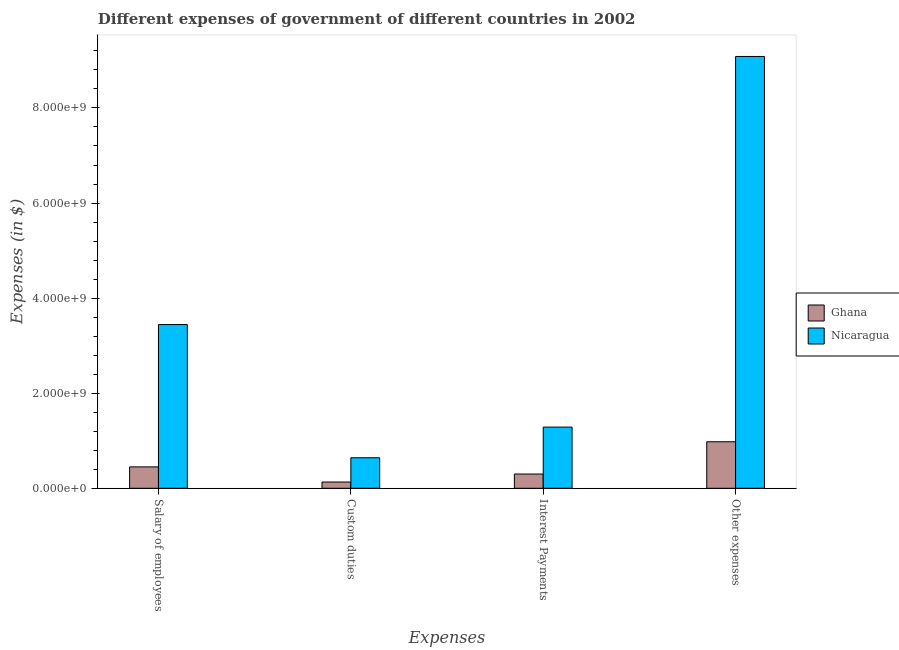How many different coloured bars are there?
Offer a terse response. 2. What is the label of the 4th group of bars from the left?
Keep it short and to the point. Other expenses. What is the amount spent on other expenses in Nicaragua?
Give a very brief answer. 9.08e+09. Across all countries, what is the maximum amount spent on custom duties?
Your answer should be compact. 6.42e+08. Across all countries, what is the minimum amount spent on interest payments?
Your response must be concise. 3.00e+08. In which country was the amount spent on interest payments maximum?
Provide a succinct answer. Nicaragua. What is the total amount spent on other expenses in the graph?
Your answer should be compact. 1.01e+1. What is the difference between the amount spent on custom duties in Nicaragua and that in Ghana?
Provide a succinct answer. 5.10e+08. What is the difference between the amount spent on salary of employees in Nicaragua and the amount spent on custom duties in Ghana?
Your response must be concise. 3.31e+09. What is the average amount spent on salary of employees per country?
Keep it short and to the point. 1.95e+09. What is the difference between the amount spent on custom duties and amount spent on interest payments in Ghana?
Your response must be concise. -1.68e+08. In how many countries, is the amount spent on salary of employees greater than 8800000000 $?
Ensure brevity in your answer.  0. What is the ratio of the amount spent on salary of employees in Nicaragua to that in Ghana?
Your answer should be very brief. 7.65. Is the difference between the amount spent on salary of employees in Nicaragua and Ghana greater than the difference between the amount spent on other expenses in Nicaragua and Ghana?
Make the answer very short. No. What is the difference between the highest and the second highest amount spent on interest payments?
Your answer should be compact. 9.87e+08. What is the difference between the highest and the lowest amount spent on interest payments?
Make the answer very short. 9.87e+08. In how many countries, is the amount spent on salary of employees greater than the average amount spent on salary of employees taken over all countries?
Provide a short and direct response. 1. Is it the case that in every country, the sum of the amount spent on salary of employees and amount spent on custom duties is greater than the sum of amount spent on other expenses and amount spent on interest payments?
Keep it short and to the point. No. What does the 1st bar from the left in Other expenses represents?
Offer a very short reply. Ghana. What does the 1st bar from the right in Interest Payments represents?
Provide a succinct answer. Nicaragua. Are the values on the major ticks of Y-axis written in scientific E-notation?
Keep it short and to the point. Yes. Does the graph contain grids?
Offer a very short reply. No. How are the legend labels stacked?
Make the answer very short. Vertical. What is the title of the graph?
Offer a terse response. Different expenses of government of different countries in 2002. What is the label or title of the X-axis?
Keep it short and to the point. Expenses. What is the label or title of the Y-axis?
Provide a succinct answer. Expenses (in $). What is the Expenses (in $) in Ghana in Salary of employees?
Ensure brevity in your answer.  4.50e+08. What is the Expenses (in $) of Nicaragua in Salary of employees?
Give a very brief answer. 3.44e+09. What is the Expenses (in $) of Ghana in Custom duties?
Offer a terse response. 1.32e+08. What is the Expenses (in $) in Nicaragua in Custom duties?
Give a very brief answer. 6.42e+08. What is the Expenses (in $) in Ghana in Interest Payments?
Give a very brief answer. 3.00e+08. What is the Expenses (in $) of Nicaragua in Interest Payments?
Provide a succinct answer. 1.29e+09. What is the Expenses (in $) in Ghana in Other expenses?
Your response must be concise. 9.79e+08. What is the Expenses (in $) in Nicaragua in Other expenses?
Keep it short and to the point. 9.08e+09. Across all Expenses, what is the maximum Expenses (in $) in Ghana?
Offer a terse response. 9.79e+08. Across all Expenses, what is the maximum Expenses (in $) of Nicaragua?
Offer a terse response. 9.08e+09. Across all Expenses, what is the minimum Expenses (in $) of Ghana?
Make the answer very short. 1.32e+08. Across all Expenses, what is the minimum Expenses (in $) of Nicaragua?
Ensure brevity in your answer.  6.42e+08. What is the total Expenses (in $) of Ghana in the graph?
Your answer should be compact. 1.86e+09. What is the total Expenses (in $) of Nicaragua in the graph?
Offer a very short reply. 1.45e+1. What is the difference between the Expenses (in $) of Ghana in Salary of employees and that in Custom duties?
Offer a terse response. 3.18e+08. What is the difference between the Expenses (in $) in Nicaragua in Salary of employees and that in Custom duties?
Make the answer very short. 2.80e+09. What is the difference between the Expenses (in $) of Ghana in Salary of employees and that in Interest Payments?
Your answer should be compact. 1.50e+08. What is the difference between the Expenses (in $) in Nicaragua in Salary of employees and that in Interest Payments?
Offer a very short reply. 2.16e+09. What is the difference between the Expenses (in $) of Ghana in Salary of employees and that in Other expenses?
Offer a very short reply. -5.29e+08. What is the difference between the Expenses (in $) of Nicaragua in Salary of employees and that in Other expenses?
Provide a succinct answer. -5.64e+09. What is the difference between the Expenses (in $) in Ghana in Custom duties and that in Interest Payments?
Make the answer very short. -1.68e+08. What is the difference between the Expenses (in $) of Nicaragua in Custom duties and that in Interest Payments?
Your answer should be compact. -6.45e+08. What is the difference between the Expenses (in $) of Ghana in Custom duties and that in Other expenses?
Provide a short and direct response. -8.47e+08. What is the difference between the Expenses (in $) in Nicaragua in Custom duties and that in Other expenses?
Offer a very short reply. -8.44e+09. What is the difference between the Expenses (in $) of Ghana in Interest Payments and that in Other expenses?
Your answer should be very brief. -6.79e+08. What is the difference between the Expenses (in $) of Nicaragua in Interest Payments and that in Other expenses?
Offer a very short reply. -7.80e+09. What is the difference between the Expenses (in $) of Ghana in Salary of employees and the Expenses (in $) of Nicaragua in Custom duties?
Provide a succinct answer. -1.92e+08. What is the difference between the Expenses (in $) of Ghana in Salary of employees and the Expenses (in $) of Nicaragua in Interest Payments?
Offer a very short reply. -8.37e+08. What is the difference between the Expenses (in $) in Ghana in Salary of employees and the Expenses (in $) in Nicaragua in Other expenses?
Give a very brief answer. -8.63e+09. What is the difference between the Expenses (in $) in Ghana in Custom duties and the Expenses (in $) in Nicaragua in Interest Payments?
Keep it short and to the point. -1.16e+09. What is the difference between the Expenses (in $) of Ghana in Custom duties and the Expenses (in $) of Nicaragua in Other expenses?
Offer a very short reply. -8.95e+09. What is the difference between the Expenses (in $) of Ghana in Interest Payments and the Expenses (in $) of Nicaragua in Other expenses?
Your answer should be compact. -8.78e+09. What is the average Expenses (in $) of Ghana per Expenses?
Your answer should be very brief. 4.65e+08. What is the average Expenses (in $) in Nicaragua per Expenses?
Give a very brief answer. 3.61e+09. What is the difference between the Expenses (in $) in Ghana and Expenses (in $) in Nicaragua in Salary of employees?
Keep it short and to the point. -2.99e+09. What is the difference between the Expenses (in $) of Ghana and Expenses (in $) of Nicaragua in Custom duties?
Provide a succinct answer. -5.10e+08. What is the difference between the Expenses (in $) in Ghana and Expenses (in $) in Nicaragua in Interest Payments?
Give a very brief answer. -9.87e+08. What is the difference between the Expenses (in $) in Ghana and Expenses (in $) in Nicaragua in Other expenses?
Your answer should be compact. -8.10e+09. What is the ratio of the Expenses (in $) in Ghana in Salary of employees to that in Custom duties?
Make the answer very short. 3.42. What is the ratio of the Expenses (in $) of Nicaragua in Salary of employees to that in Custom duties?
Make the answer very short. 5.36. What is the ratio of the Expenses (in $) in Ghana in Salary of employees to that in Interest Payments?
Your answer should be very brief. 1.5. What is the ratio of the Expenses (in $) of Nicaragua in Salary of employees to that in Interest Payments?
Your answer should be compact. 2.68. What is the ratio of the Expenses (in $) in Ghana in Salary of employees to that in Other expenses?
Provide a succinct answer. 0.46. What is the ratio of the Expenses (in $) in Nicaragua in Salary of employees to that in Other expenses?
Your answer should be very brief. 0.38. What is the ratio of the Expenses (in $) of Ghana in Custom duties to that in Interest Payments?
Your answer should be compact. 0.44. What is the ratio of the Expenses (in $) of Nicaragua in Custom duties to that in Interest Payments?
Ensure brevity in your answer.  0.5. What is the ratio of the Expenses (in $) of Ghana in Custom duties to that in Other expenses?
Provide a short and direct response. 0.13. What is the ratio of the Expenses (in $) of Nicaragua in Custom duties to that in Other expenses?
Provide a short and direct response. 0.07. What is the ratio of the Expenses (in $) in Ghana in Interest Payments to that in Other expenses?
Give a very brief answer. 0.31. What is the ratio of the Expenses (in $) of Nicaragua in Interest Payments to that in Other expenses?
Your answer should be very brief. 0.14. What is the difference between the highest and the second highest Expenses (in $) of Ghana?
Your answer should be compact. 5.29e+08. What is the difference between the highest and the second highest Expenses (in $) in Nicaragua?
Provide a succinct answer. 5.64e+09. What is the difference between the highest and the lowest Expenses (in $) of Ghana?
Your response must be concise. 8.47e+08. What is the difference between the highest and the lowest Expenses (in $) in Nicaragua?
Provide a short and direct response. 8.44e+09. 